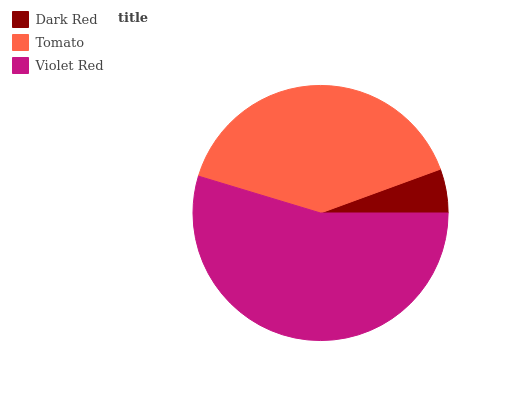Is Dark Red the minimum?
Answer yes or no. Yes. Is Violet Red the maximum?
Answer yes or no. Yes. Is Tomato the minimum?
Answer yes or no. No. Is Tomato the maximum?
Answer yes or no. No. Is Tomato greater than Dark Red?
Answer yes or no. Yes. Is Dark Red less than Tomato?
Answer yes or no. Yes. Is Dark Red greater than Tomato?
Answer yes or no. No. Is Tomato less than Dark Red?
Answer yes or no. No. Is Tomato the high median?
Answer yes or no. Yes. Is Tomato the low median?
Answer yes or no. Yes. Is Violet Red the high median?
Answer yes or no. No. Is Dark Red the low median?
Answer yes or no. No. 